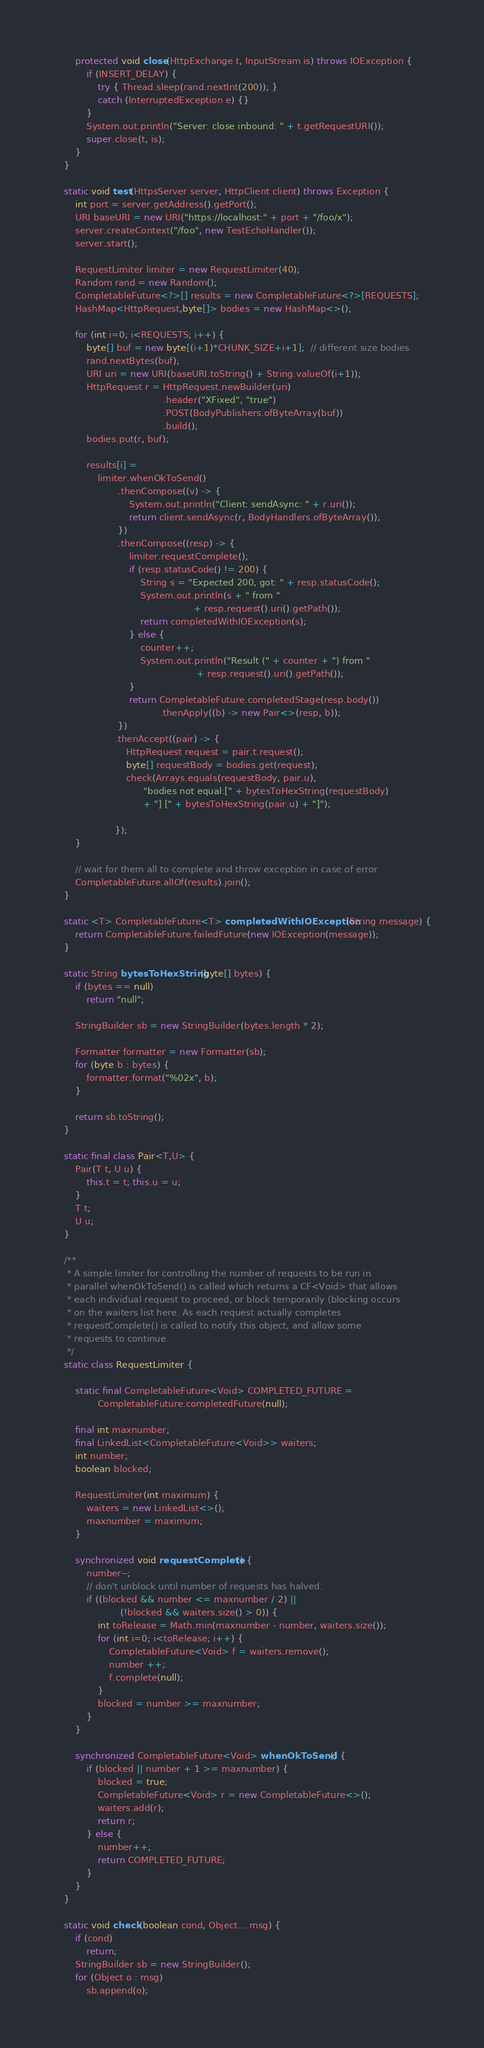<code> <loc_0><loc_0><loc_500><loc_500><_Java_>        protected void close(HttpExchange t, InputStream is) throws IOException {
            if (INSERT_DELAY) {
                try { Thread.sleep(rand.nextInt(200)); }
                catch (InterruptedException e) {}
            }
            System.out.println("Server: close inbound: " + t.getRequestURI());
            super.close(t, is);
        }
    }

    static void test(HttpsServer server, HttpClient client) throws Exception {
        int port = server.getAddress().getPort();
        URI baseURI = new URI("https://localhost:" + port + "/foo/x");
        server.createContext("/foo", new TestEchoHandler());
        server.start();

        RequestLimiter limiter = new RequestLimiter(40);
        Random rand = new Random();
        CompletableFuture<?>[] results = new CompletableFuture<?>[REQUESTS];
        HashMap<HttpRequest,byte[]> bodies = new HashMap<>();

        for (int i=0; i<REQUESTS; i++) {
            byte[] buf = new byte[(i+1)*CHUNK_SIZE+i+1];  // different size bodies
            rand.nextBytes(buf);
            URI uri = new URI(baseURI.toString() + String.valueOf(i+1));
            HttpRequest r = HttpRequest.newBuilder(uri)
                                       .header("XFixed", "true")
                                       .POST(BodyPublishers.ofByteArray(buf))
                                       .build();
            bodies.put(r, buf);

            results[i] =
                limiter.whenOkToSend()
                       .thenCompose((v) -> {
                           System.out.println("Client: sendAsync: " + r.uri());
                           return client.sendAsync(r, BodyHandlers.ofByteArray());
                       })
                       .thenCompose((resp) -> {
                           limiter.requestComplete();
                           if (resp.statusCode() != 200) {
                               String s = "Expected 200, got: " + resp.statusCode();
                               System.out.println(s + " from "
                                                  + resp.request().uri().getPath());
                               return completedWithIOException(s);
                           } else {
                               counter++;
                               System.out.println("Result (" + counter + ") from "
                                                   + resp.request().uri().getPath());
                           }
                           return CompletableFuture.completedStage(resp.body())
                                      .thenApply((b) -> new Pair<>(resp, b));
                       })
                      .thenAccept((pair) -> {
                          HttpRequest request = pair.t.request();
                          byte[] requestBody = bodies.get(request);
                          check(Arrays.equals(requestBody, pair.u),
                                "bodies not equal:[" + bytesToHexString(requestBody)
                                + "] [" + bytesToHexString(pair.u) + "]");

                      });
        }

        // wait for them all to complete and throw exception in case of error
        CompletableFuture.allOf(results).join();
    }

    static <T> CompletableFuture<T> completedWithIOException(String message) {
        return CompletableFuture.failedFuture(new IOException(message));
    }

    static String bytesToHexString(byte[] bytes) {
        if (bytes == null)
            return "null";

        StringBuilder sb = new StringBuilder(bytes.length * 2);

        Formatter formatter = new Formatter(sb);
        for (byte b : bytes) {
            formatter.format("%02x", b);
        }

        return sb.toString();
    }

    static final class Pair<T,U> {
        Pair(T t, U u) {
            this.t = t; this.u = u;
        }
        T t;
        U u;
    }

    /**
     * A simple limiter for controlling the number of requests to be run in
     * parallel whenOkToSend() is called which returns a CF<Void> that allows
     * each individual request to proceed, or block temporarily (blocking occurs
     * on the waiters list here. As each request actually completes
     * requestComplete() is called to notify this object, and allow some
     * requests to continue.
     */
    static class RequestLimiter {

        static final CompletableFuture<Void> COMPLETED_FUTURE =
                CompletableFuture.completedFuture(null);

        final int maxnumber;
        final LinkedList<CompletableFuture<Void>> waiters;
        int number;
        boolean blocked;

        RequestLimiter(int maximum) {
            waiters = new LinkedList<>();
            maxnumber = maximum;
        }

        synchronized void requestComplete() {
            number--;
            // don't unblock until number of requests has halved.
            if ((blocked && number <= maxnumber / 2) ||
                        (!blocked && waiters.size() > 0)) {
                int toRelease = Math.min(maxnumber - number, waiters.size());
                for (int i=0; i<toRelease; i++) {
                    CompletableFuture<Void> f = waiters.remove();
                    number ++;
                    f.complete(null);
                }
                blocked = number >= maxnumber;
            }
        }

        synchronized CompletableFuture<Void> whenOkToSend() {
            if (blocked || number + 1 >= maxnumber) {
                blocked = true;
                CompletableFuture<Void> r = new CompletableFuture<>();
                waiters.add(r);
                return r;
            } else {
                number++;
                return COMPLETED_FUTURE;
            }
        }
    }

    static void check(boolean cond, Object... msg) {
        if (cond)
            return;
        StringBuilder sb = new StringBuilder();
        for (Object o : msg)
            sb.append(o);</code> 